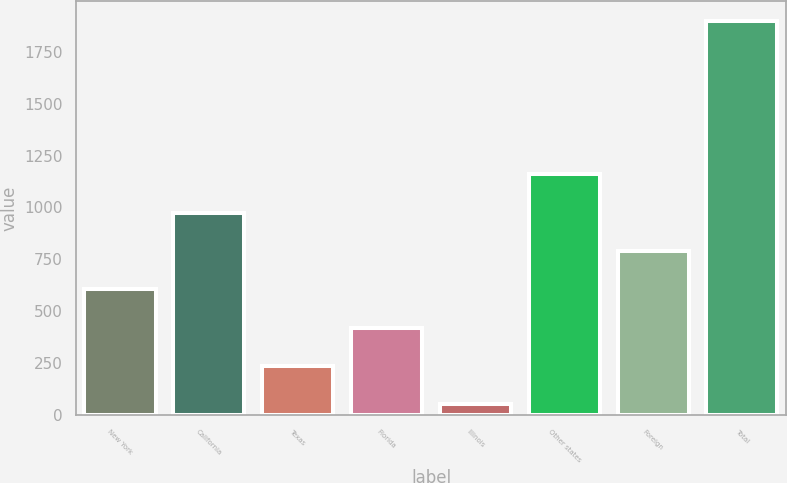Convert chart. <chart><loc_0><loc_0><loc_500><loc_500><bar_chart><fcel>New York<fcel>California<fcel>Texas<fcel>Florida<fcel>Illinois<fcel>Other states<fcel>Foreign<fcel>Total<nl><fcel>605.8<fcel>975<fcel>236.6<fcel>421.2<fcel>52<fcel>1159.6<fcel>790.4<fcel>1898<nl></chart> 